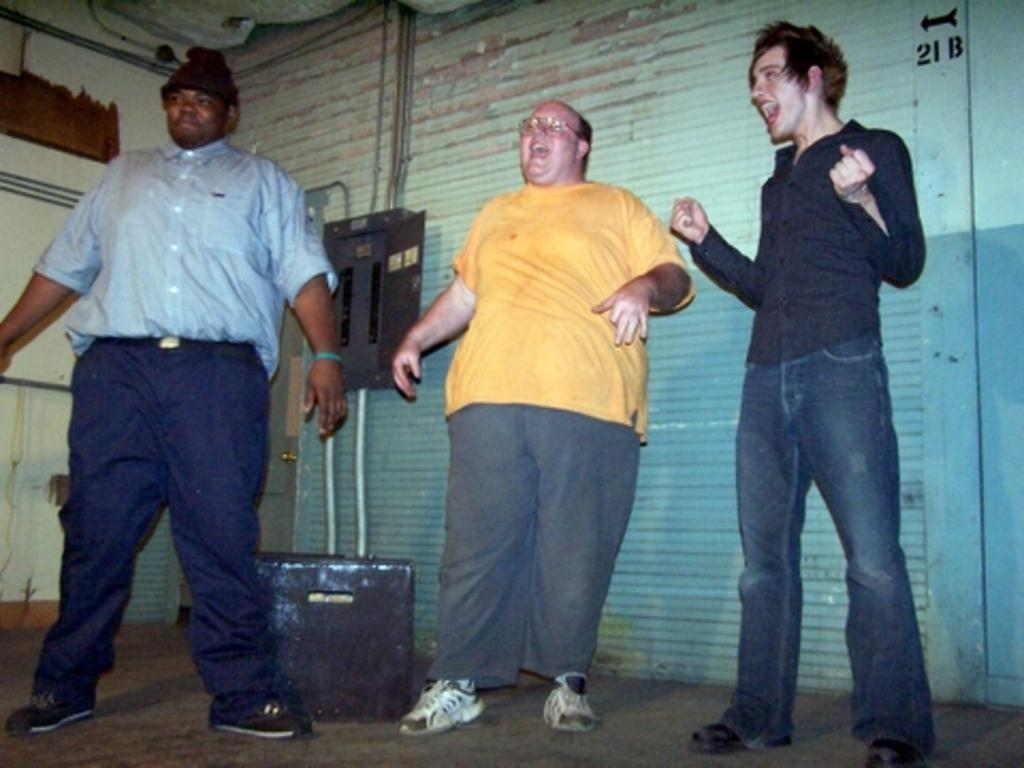What type of structure is present in the image? There is a wall in the image. What is the other main object in the image? There is a rolling shutter in the image. How many people are standing in the image? There are three people standing in the image. What color is the orange in the image? There is no orange present in the image. What action are the people performing in the image? The image does not show the people performing any specific action. What type of material is the yarn made of in the image? There is no yarn present in the image. 